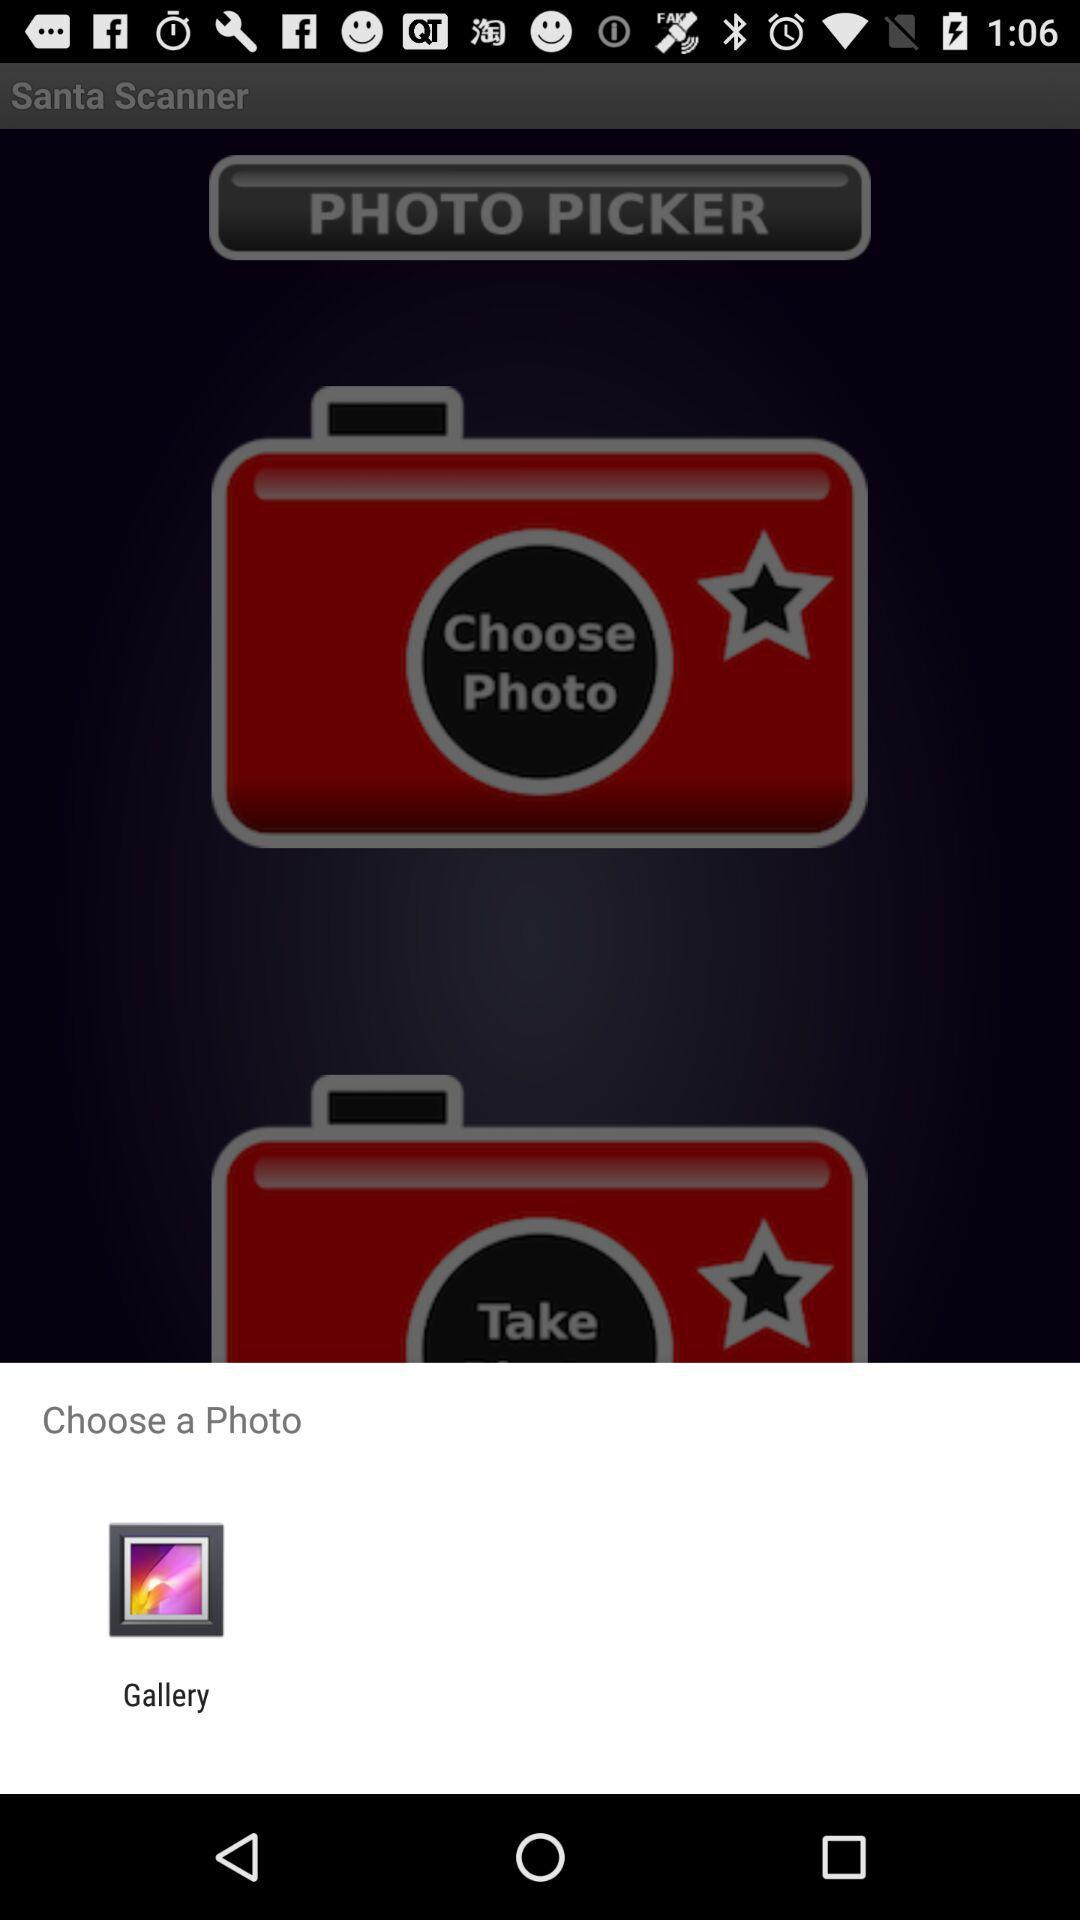How many photos can be chosen?
When the provided information is insufficient, respond with <no answer>. <no answer> 